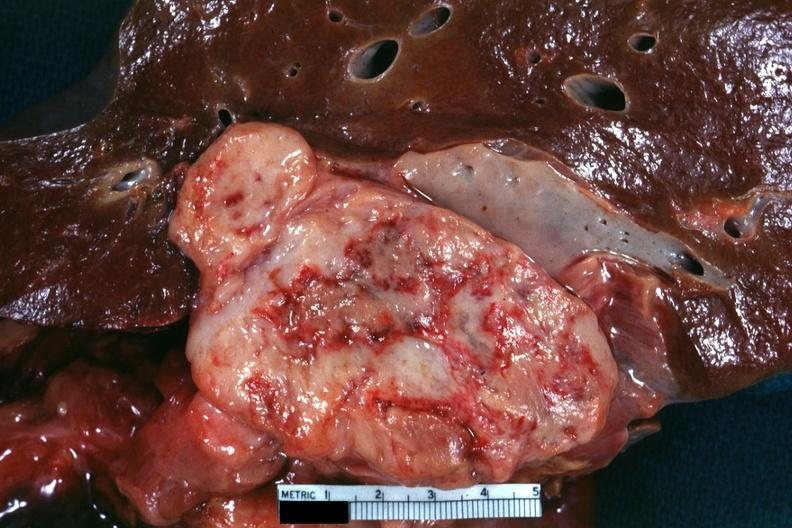s retroperitoneum present?
Answer the question using a single word or phrase. Yes 